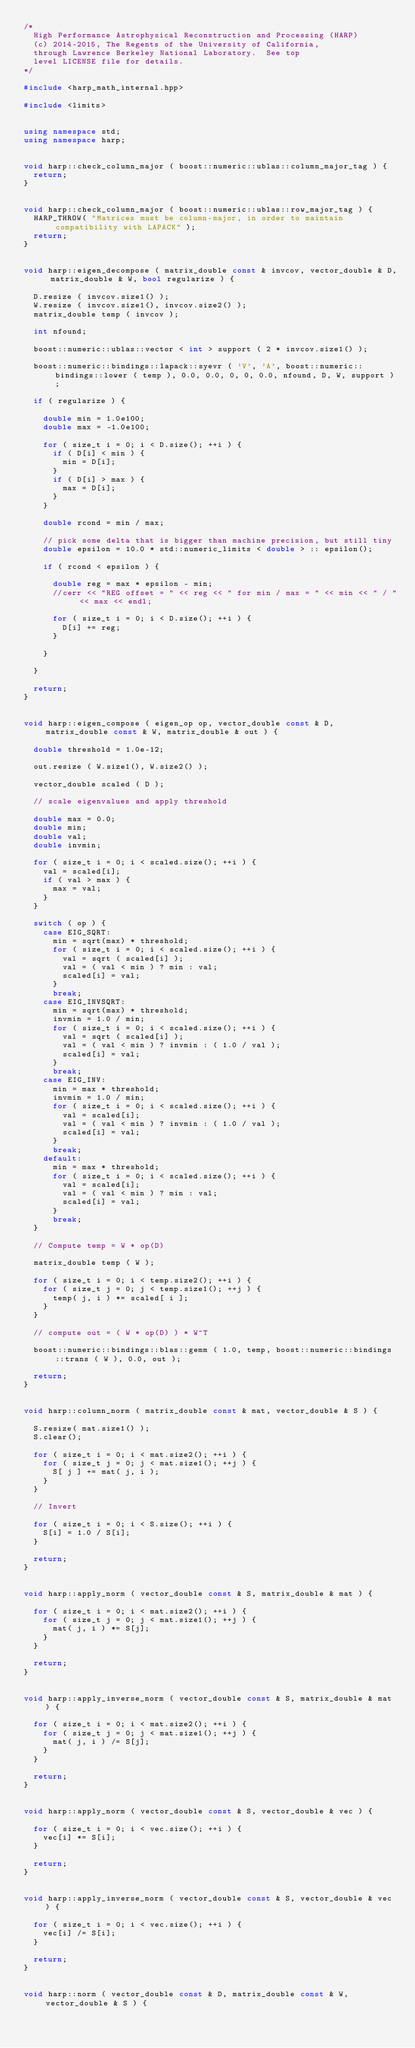Convert code to text. <code><loc_0><loc_0><loc_500><loc_500><_C++_>/*
  High Performance Astrophysical Reconstruction and Processing (HARP)
  (c) 2014-2015, The Regents of the University of California, 
  through Lawrence Berkeley National Laboratory.  See top
  level LICENSE file for details.
*/

#include <harp_math_internal.hpp>

#include <limits>


using namespace std;
using namespace harp;


void harp::check_column_major ( boost::numeric::ublas::column_major_tag ) {
  return;
}


void harp::check_column_major ( boost::numeric::ublas::row_major_tag ) {
  HARP_THROW( "Matrices must be column-major, in order to maintain compatibility with LAPACK" );
  return;
}


void harp::eigen_decompose ( matrix_double const & invcov, vector_double & D, matrix_double & W, bool regularize ) {

  D.resize ( invcov.size1() );
  W.resize ( invcov.size1(), invcov.size2() );
  matrix_double temp ( invcov );

  int nfound;

  boost::numeric::ublas::vector < int > support ( 2 * invcov.size1() );

  boost::numeric::bindings::lapack::syevr ( 'V', 'A', boost::numeric::bindings::lower ( temp ), 0.0, 0.0, 0, 0, 0.0, nfound, D, W, support );

  if ( regularize ) {
    
    double min = 1.0e100;
    double max = -1.0e100;

    for ( size_t i = 0; i < D.size(); ++i ) {
      if ( D[i] < min ) {
        min = D[i];
      }
      if ( D[i] > max ) {
        max = D[i];
      }
    }

    double rcond = min / max;

    // pick some delta that is bigger than machine precision, but still tiny
    double epsilon = 10.0 * std::numeric_limits < double > :: epsilon();

    if ( rcond < epsilon ) {

      double reg = max * epsilon - min;
      //cerr << "REG offset = " << reg << " for min / max = " << min << " / " << max << endl;

      for ( size_t i = 0; i < D.size(); ++i ) {
        D[i] += reg;
      }

    }

  }

  return;
}


void harp::eigen_compose ( eigen_op op, vector_double const & D, matrix_double const & W, matrix_double & out ) {

  double threshold = 1.0e-12;

  out.resize ( W.size1(), W.size2() );

  vector_double scaled ( D );

  // scale eigenvalues and apply threshold

  double max = 0.0;
  double min;
  double val;
  double invmin;

  for ( size_t i = 0; i < scaled.size(); ++i ) {
    val = scaled[i];
    if ( val > max ) {
      max = val;
    }
  }

  switch ( op ) {
    case EIG_SQRT:
      min = sqrt(max) * threshold;
      for ( size_t i = 0; i < scaled.size(); ++i ) {
        val = sqrt ( scaled[i] );
        val = ( val < min ) ? min : val;
        scaled[i] = val;
      }
      break;
    case EIG_INVSQRT:
      min = sqrt(max) * threshold;
      invmin = 1.0 / min;
      for ( size_t i = 0; i < scaled.size(); ++i ) {
        val = sqrt ( scaled[i] );
        val = ( val < min ) ? invmin : ( 1.0 / val );
        scaled[i] = val;
      }
      break;
    case EIG_INV:
      min = max * threshold;
      invmin = 1.0 / min;
      for ( size_t i = 0; i < scaled.size(); ++i ) {
        val = scaled[i];
        val = ( val < min ) ? invmin : ( 1.0 / val );
        scaled[i] = val;
      }
      break;
    default:
      min = max * threshold;
      for ( size_t i = 0; i < scaled.size(); ++i ) {
        val = scaled[i];
        val = ( val < min ) ? min : val;
        scaled[i] = val;
      }
      break;
  }

  // Compute temp = W * op(D)

  matrix_double temp ( W );

  for ( size_t i = 0; i < temp.size2(); ++i ) {
    for ( size_t j = 0; j < temp.size1(); ++j ) {
      temp( j, i ) *= scaled[ i ];
    }
  }

  // compute out = ( W * op(D) ) * W^T

  boost::numeric::bindings::blas::gemm ( 1.0, temp, boost::numeric::bindings::trans ( W ), 0.0, out );

  return;
}


void harp::column_norm ( matrix_double const & mat, vector_double & S ) {

  S.resize( mat.size1() );
  S.clear();

  for ( size_t i = 0; i < mat.size2(); ++i ) {
    for ( size_t j = 0; j < mat.size1(); ++j ) {
      S[ j ] += mat( j, i );
    }
  }

  // Invert

  for ( size_t i = 0; i < S.size(); ++i ) {
    S[i] = 1.0 / S[i];
  }

  return;
}


void harp::apply_norm ( vector_double const & S, matrix_double & mat ) {

  for ( size_t i = 0; i < mat.size2(); ++i ) {
    for ( size_t j = 0; j < mat.size1(); ++j ) {
      mat( j, i ) *= S[j];
    }
  }

  return;
}


void harp::apply_inverse_norm ( vector_double const & S, matrix_double & mat ) {

  for ( size_t i = 0; i < mat.size2(); ++i ) {
    for ( size_t j = 0; j < mat.size1(); ++j ) {
      mat( j, i ) /= S[j];
    }
  }

  return;
}


void harp::apply_norm ( vector_double const & S, vector_double & vec ) {

  for ( size_t i = 0; i < vec.size(); ++i ) {
    vec[i] *= S[i];
  }

  return;
}


void harp::apply_inverse_norm ( vector_double const & S, vector_double & vec ) {

  for ( size_t i = 0; i < vec.size(); ++i ) {
    vec[i] /= S[i];
  }

  return;
}


void harp::norm ( vector_double const & D, matrix_double const & W, vector_double & S ) {
</code> 